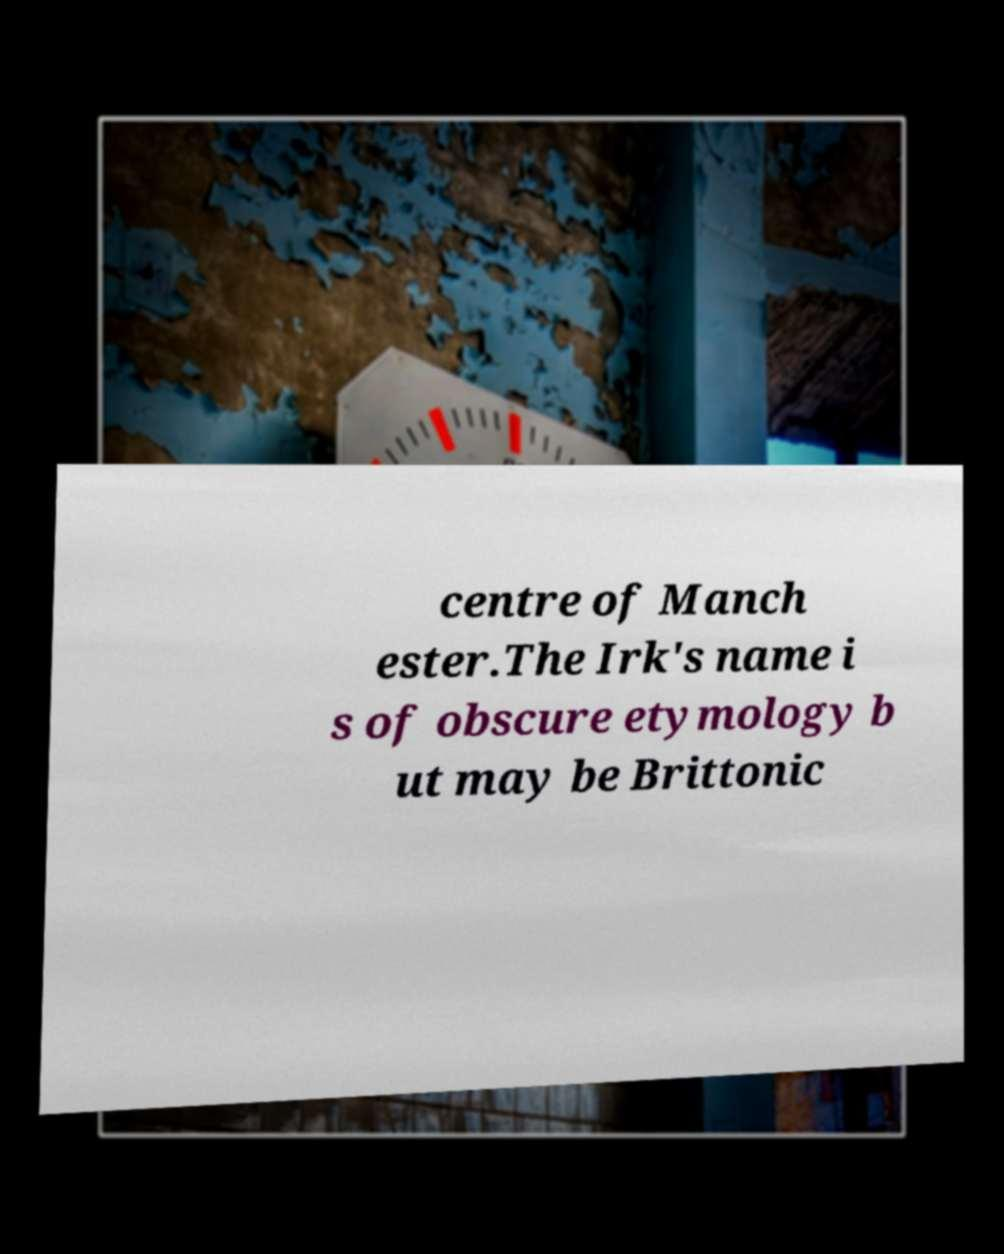What messages or text are displayed in this image? I need them in a readable, typed format. centre of Manch ester.The Irk's name i s of obscure etymology b ut may be Brittonic 